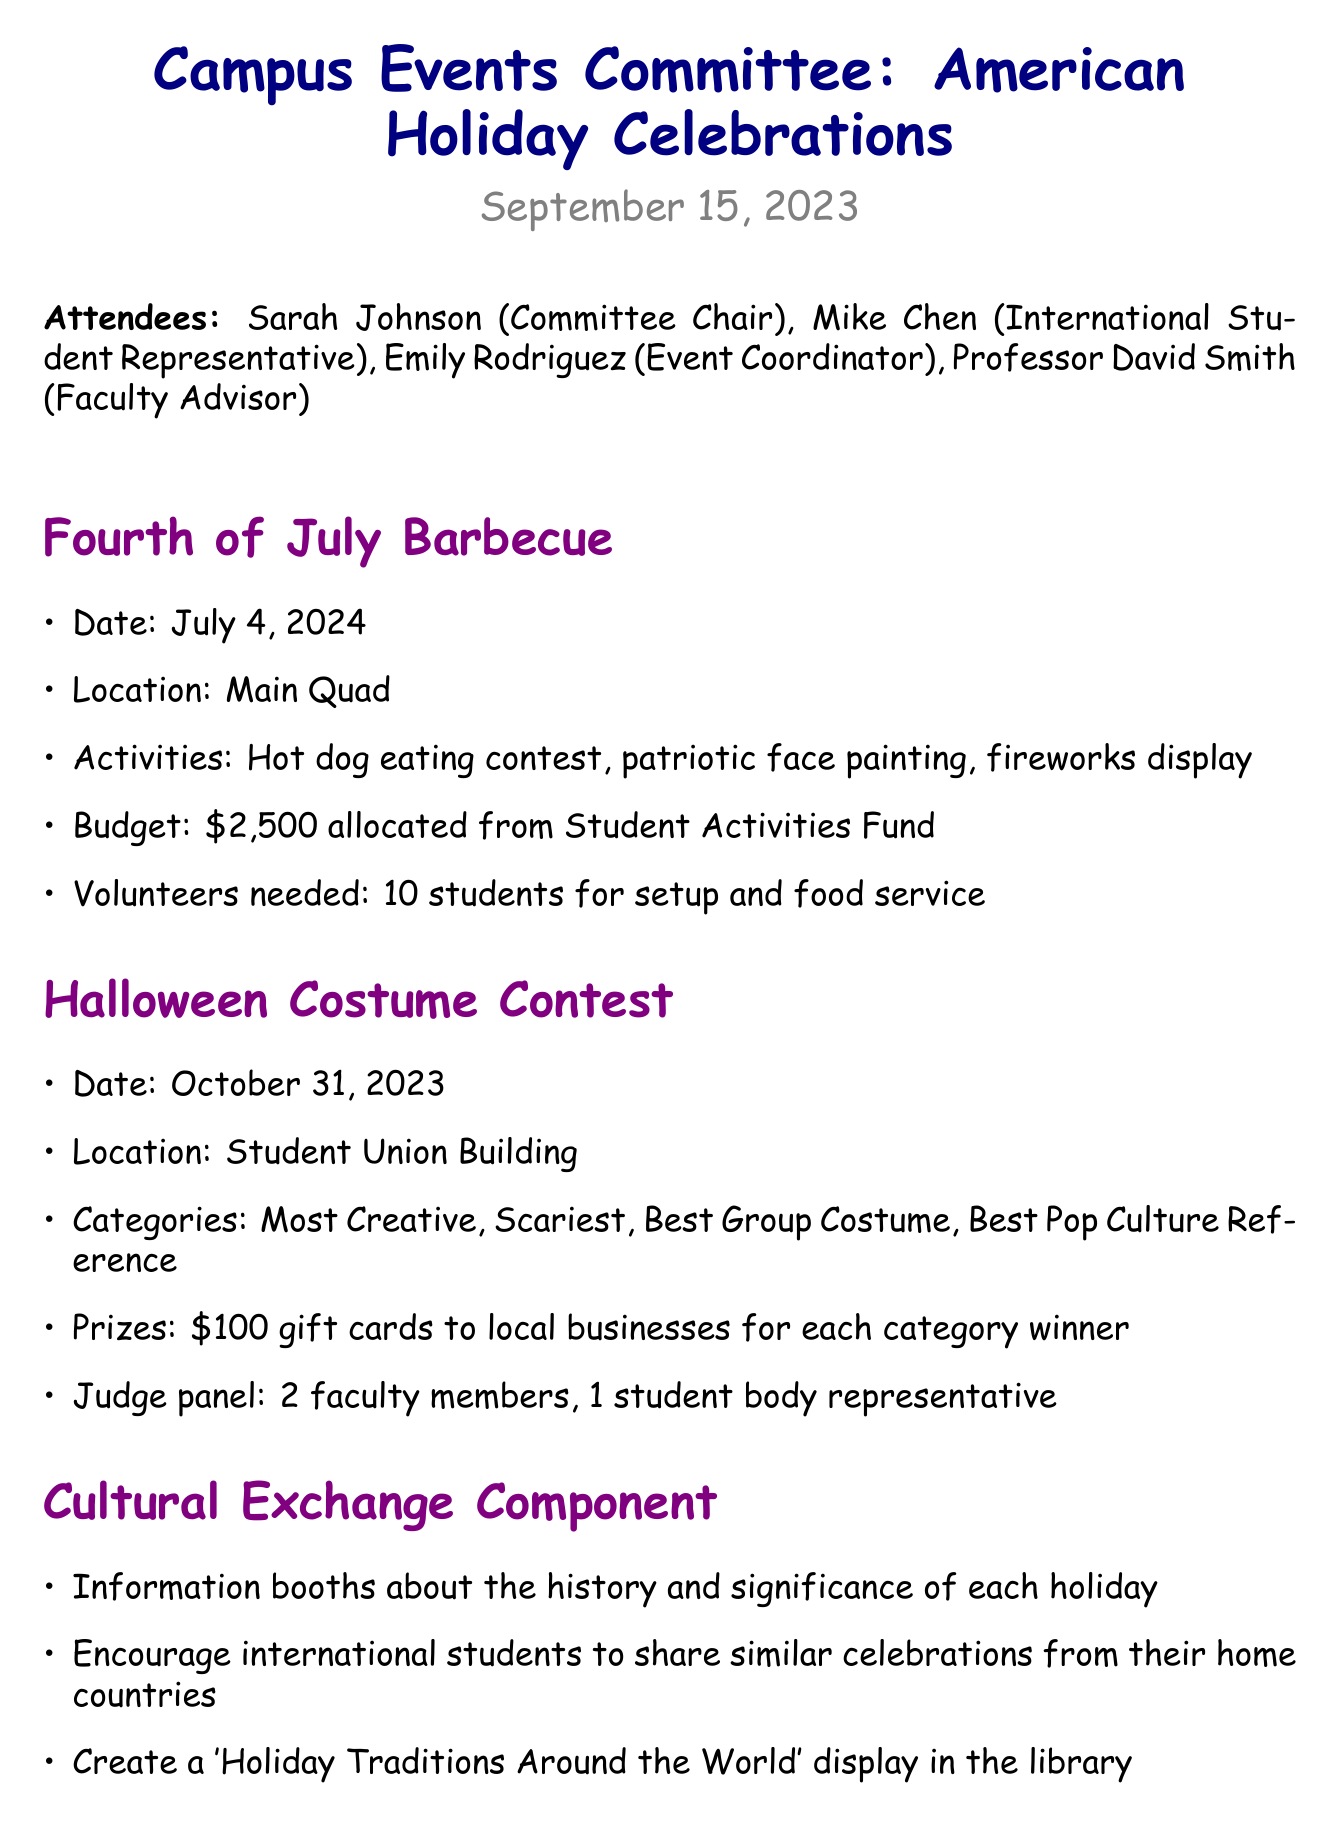What is the date of the Fourth of July barbecue? The date is specifically mentioned in the details of the barbecue section.
Answer: July 4, 2024 Where will the Halloween Costume Contest be held? The location is provided in the details section for the Halloween Costume Contest.
Answer: Student Union Building How many categories are there in the Halloween Costume Contest? The number of categories is explicitly listed in the details of the contest section.
Answer: Four Who is responsible for finalizing catering options for the barbecue? This information is found in the action items section, which assigns responsibilities.
Answer: Emily What is the budget allocated for the Fourth of July barbecue? The budget is stated clearly in the details for the barbecue.
Answer: $2,500 What type of display will be created in the library? This is mentioned in the Cultural Exchange Component of the meeting minutes.
Answer: 'Holiday Traditions Around the World' display How many volunteers are needed for the barbecue setup? The number of volunteers required is specified in the BBQ details.
Answer: 10 students What is one method mentioned for promoting the events? Promotion methods are outlined in the Promotion and Outreach section.
Answer: Facebook event pages When is the Halloween Costume Contest scheduled? The date is clearly stated in the details of the Halloween section.
Answer: October 31, 2023 